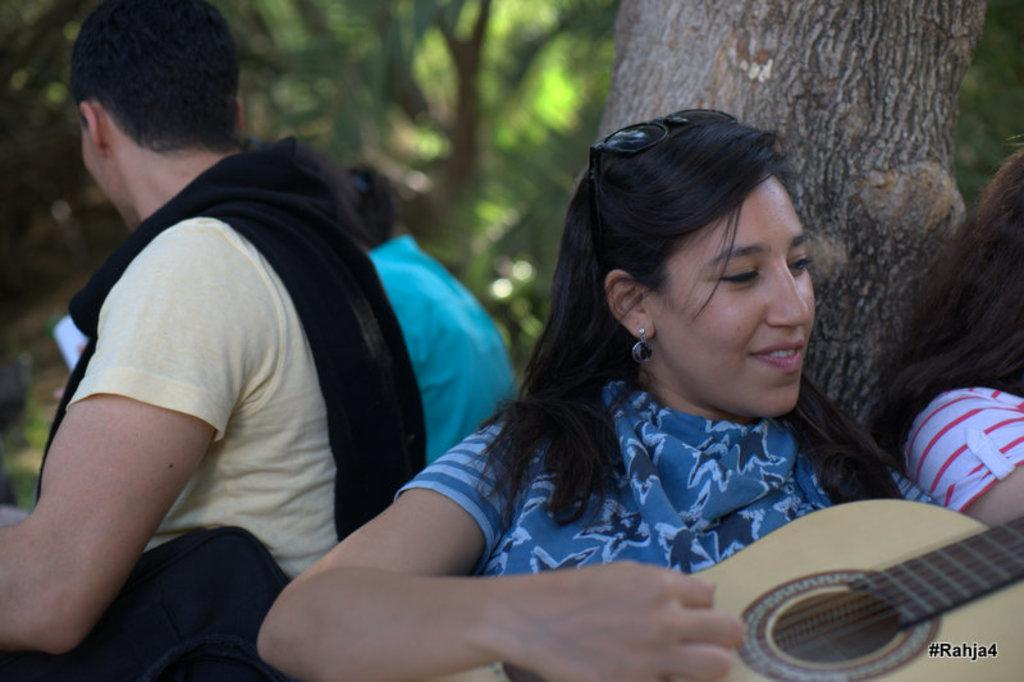Where was the image taken? The image was taken outdoors. What are the people in the image doing? There is a group of people sitting on the floor. What is the woman holding in the image? The woman is holding a guitar. What is the woman wearing in the image? The woman is wearing a blue dress. What can be seen in the background of the image? There are trees visible in the background. What advice does the manager give to the crying father in the image? There is no manager or crying father present in the image. 